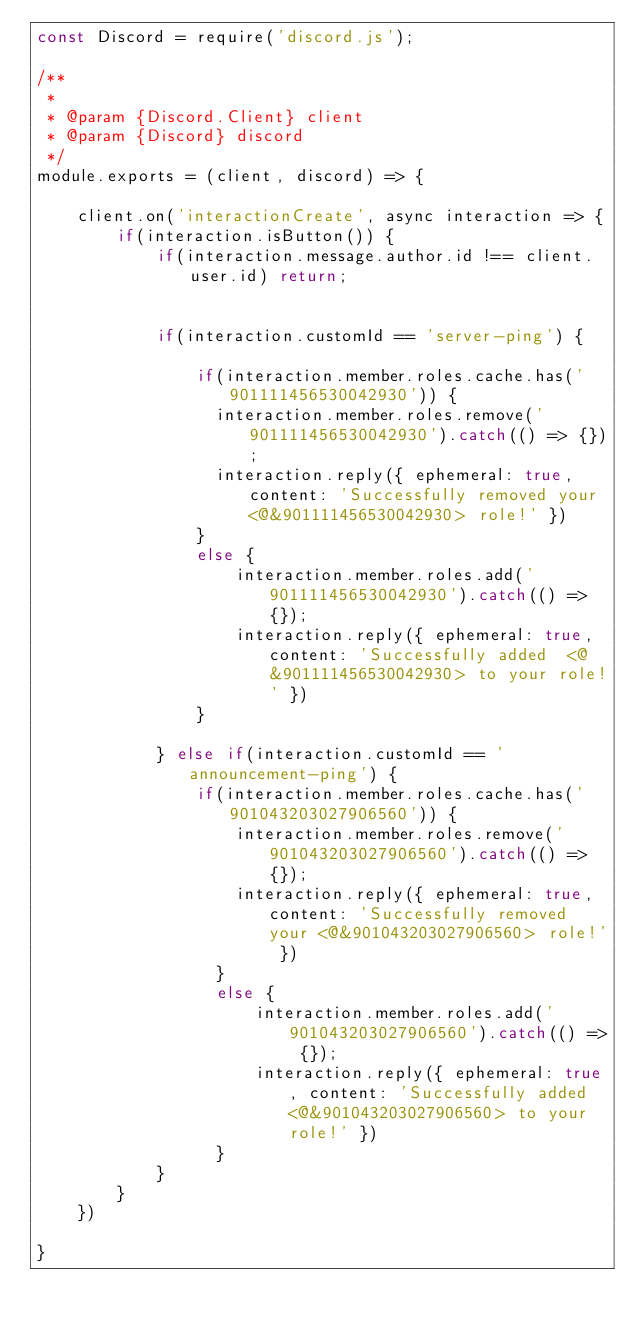Convert code to text. <code><loc_0><loc_0><loc_500><loc_500><_JavaScript_>const Discord = require('discord.js');

/**
 * 
 * @param {Discord.Client} client 
 * @param {Discord} discord 
 */
module.exports = (client, discord) => {

    client.on('interactionCreate', async interaction => {
        if(interaction.isButton()) {
            if(interaction.message.author.id !== client.user.id) return;


            if(interaction.customId == 'server-ping') {

                if(interaction.member.roles.cache.has('901111456530042930')) {
                  interaction.member.roles.remove('901111456530042930').catch(() => {});
                  interaction.reply({ ephemeral: true, content: 'Successfully removed your <@&901111456530042930> role!' })
                }
                else {
                    interaction.member.roles.add('901111456530042930').catch(() => {});
                    interaction.reply({ ephemeral: true, content: 'Successfully added  <@&901111456530042930> to your role!' })
                }

            } else if(interaction.customId == 'announcement-ping') {
                if(interaction.member.roles.cache.has('901043203027906560')) {
                    interaction.member.roles.remove('901043203027906560').catch(() => {});
                    interaction.reply({ ephemeral: true, content: 'Successfully removed your <@&901043203027906560> role!' })
                  }
                  else {
                      interaction.member.roles.add('901043203027906560').catch(() => {});
                      interaction.reply({ ephemeral: true, content: 'Successfully added  <@&901043203027906560> to your role!' })
                  }
            }
        }
    })

}</code> 